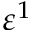Convert formula to latex. <formula><loc_0><loc_0><loc_500><loc_500>\varepsilon ^ { 1 }</formula> 